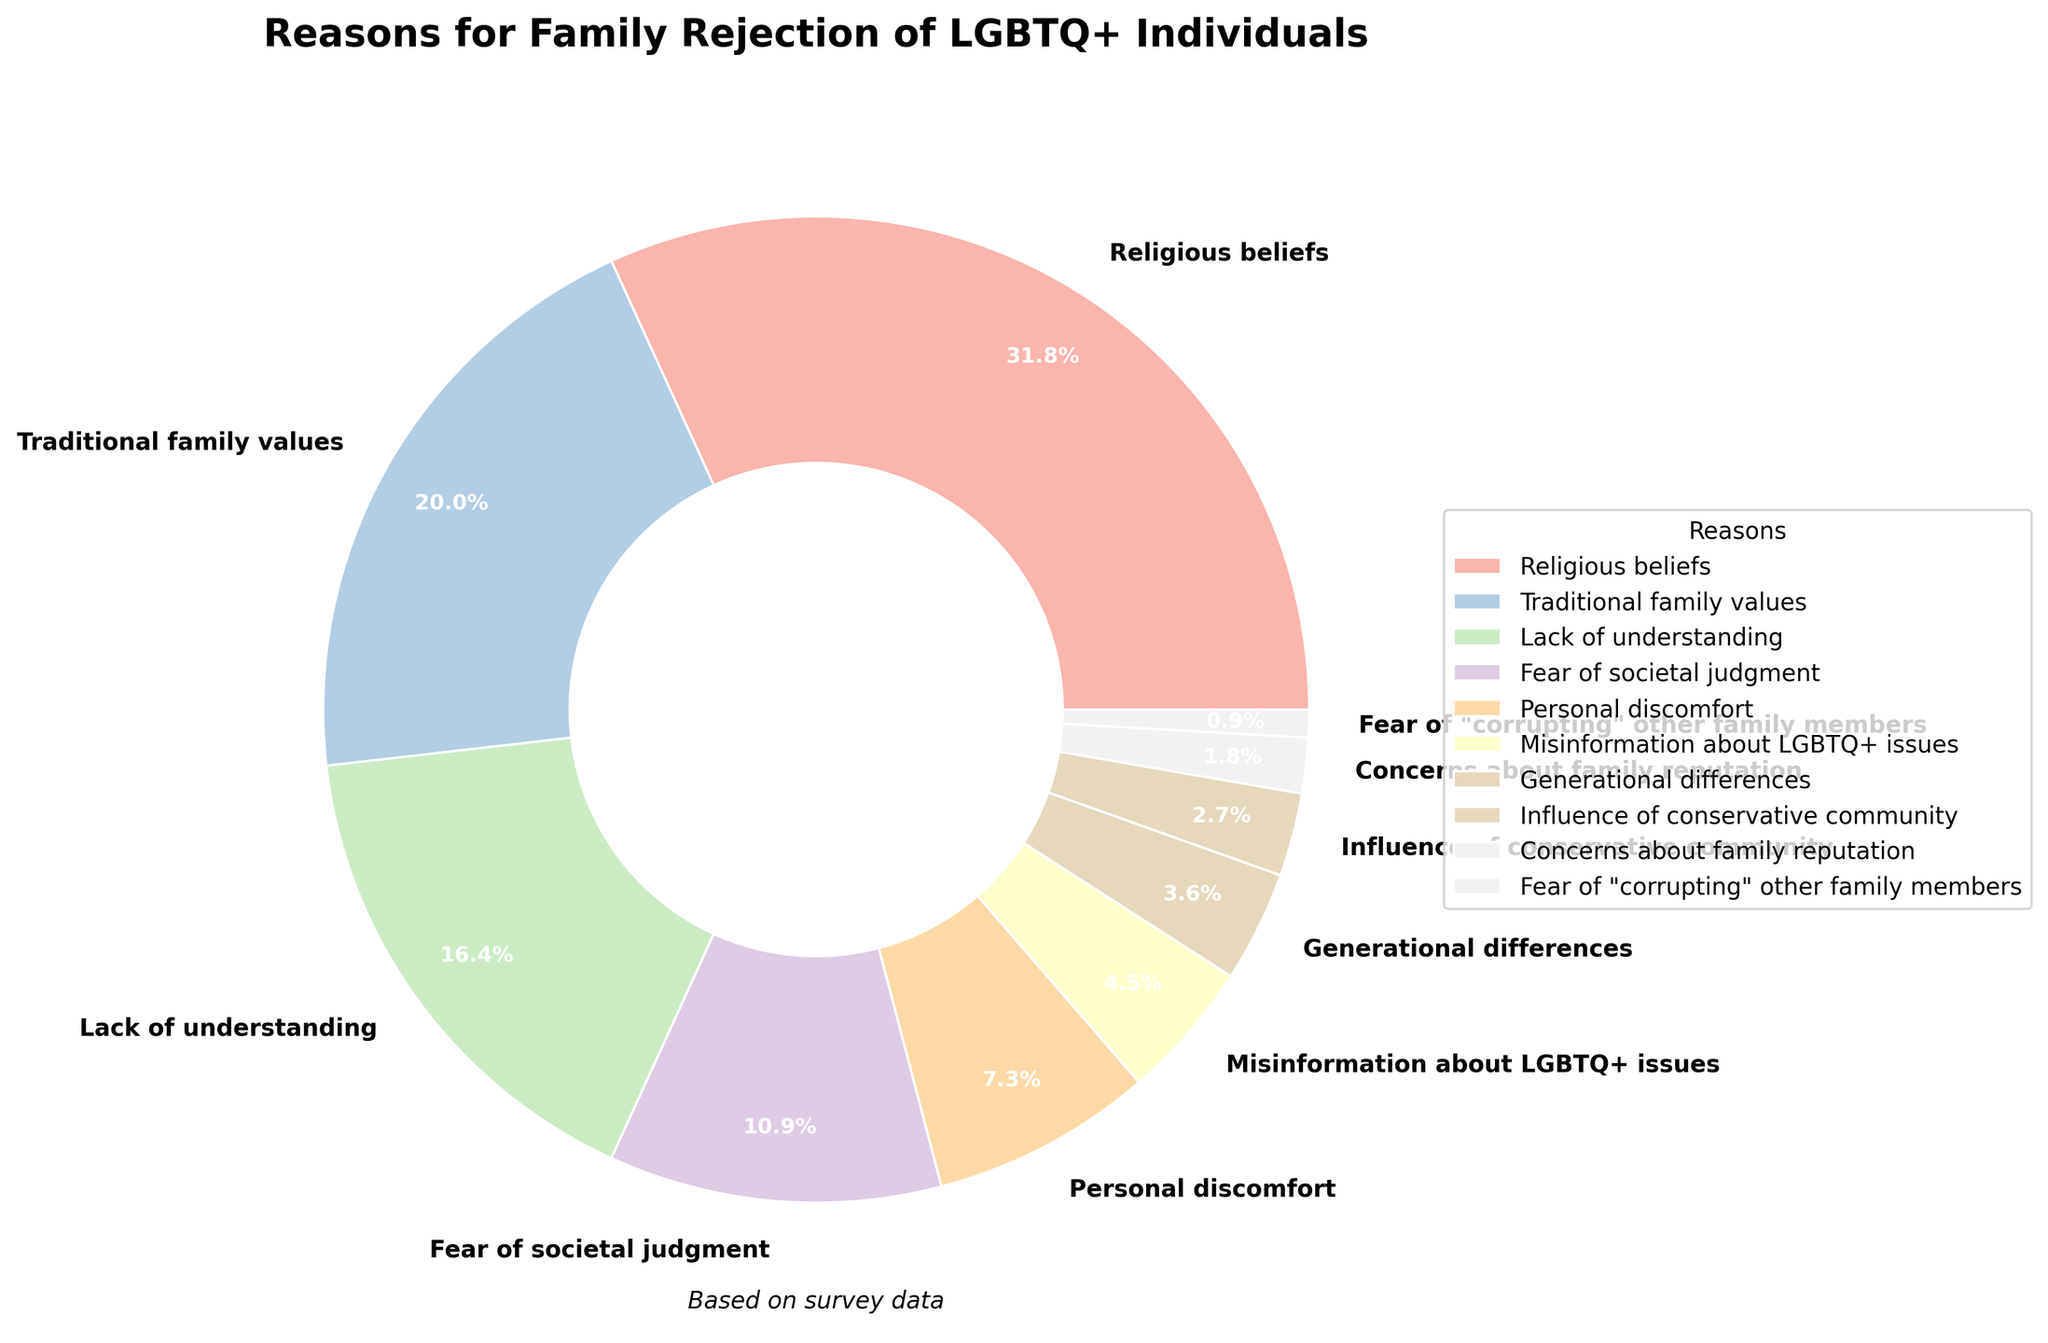What percentage of family rejection reasons are related to religious beliefs, traditional family values, and lack of understanding combined? First, identify the percentages for "Religious beliefs" (35%), "Traditional family values" (22%), and "Lack of understanding" (18%). Then, sum these values: 35 + 22 + 18 = 75. Thus, the combined percentage is 75%.
Answer: 75% What is the most common reason for family rejection of LGBTQ+ individuals? The wedge with the largest percentage represents the most common reason. According to the chart, "Religious beliefs" has the highest percentage at 35%.
Answer: Religious beliefs Which reasons for family rejection have percentages less than 5%? Locate all slices that represent percentages less than 5%. These are: "Generational differences" (4%), "Influence of conservative community" (3%), "Concerns about family reputation" (2%), and "Fear of 'corrupting' other family members" (1%).
Answer: Generational differences, Influence of conservative community, Concerns about family reputation, Fear of 'corrupting' other family members How much more significant is "Religious beliefs" than "Traditional family values" in terms of percentage points? Identify the percentages for "Religious beliefs" (35%) and "Traditional family values" (22%). Subtract the two values: 35 - 22 = 13. "Religious beliefs" is 13 percentage points more significant.
Answer: 13 percentage points What percentage of family rejection reasons stem from personal discomfort and misinformation combined? Identify the percentages for "Personal discomfort" (8%) and "Misinformation about LGBTQ+ issues" (5%). Then, sum these values: 8 + 5 = 13. Thus, the combined percentage is 13%.
Answer: 13% What is the difference between the smallest and the largest values in the reasons for rejection? The smallest value is "Fear of 'corrupting' other family members" at 1%, and the largest is "Religious beliefs" at 35%. Subtract the smallest from the largest: 35 - 1 = 34.
Answer: 34 percentage points What color is used to represent "Traditional family values" in the pie chart? Locate the "Traditional family values" label in the legend or in the pie slices. The color should correspond to the visual attribute. Since it's not specified, check the actual plot. As per the given palette, it's assigned a distinct pastel color.
Answer: Check Plot Which reason accounts for just over one-tenth of the family rejection cases? Identify the reason with a percentage just over one-tenth (10%). According to the chart, "Fear of societal judgment" accounts for 12%, which is just over one-tenth.
Answer: Fear of societal judgment By how much do traditional family values and religious beliefs combined surpass all other reasons together? Sum the percentages for "Religious beliefs" (35%) and "Traditional family values" (22%) to get 57%. Sum the percentages for all other reasons (100% - 57%) = 43%. Calculate the difference: 57 - 43 = 14.
Answer: 14 percentage points 